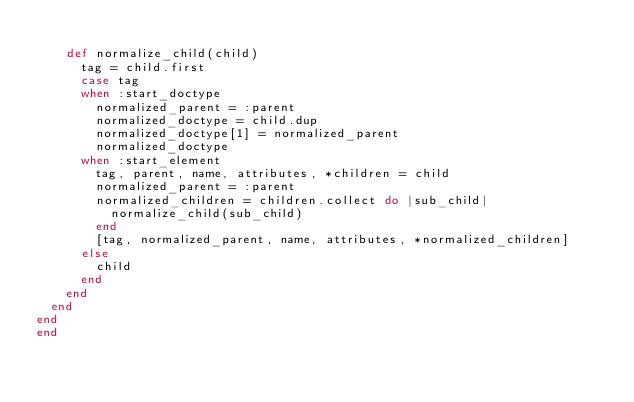<code> <loc_0><loc_0><loc_500><loc_500><_Ruby_>
    def normalize_child(child)
      tag = child.first
      case tag
      when :start_doctype
        normalized_parent = :parent
        normalized_doctype = child.dup
        normalized_doctype[1] = normalized_parent
        normalized_doctype
      when :start_element
        tag, parent, name, attributes, *children = child
        normalized_parent = :parent
        normalized_children = children.collect do |sub_child|
          normalize_child(sub_child)
        end
        [tag, normalized_parent, name, attributes, *normalized_children]
      else
        child
      end
    end
  end
end
end
</code> 